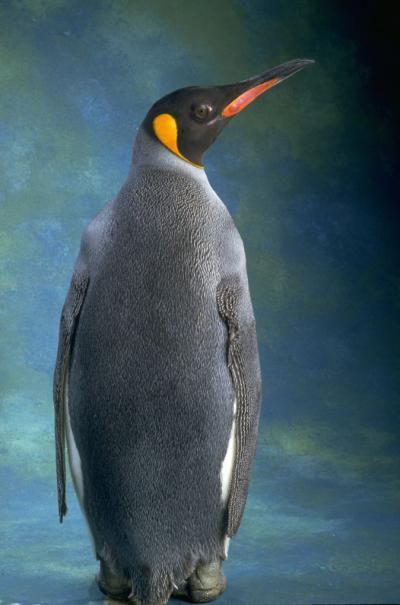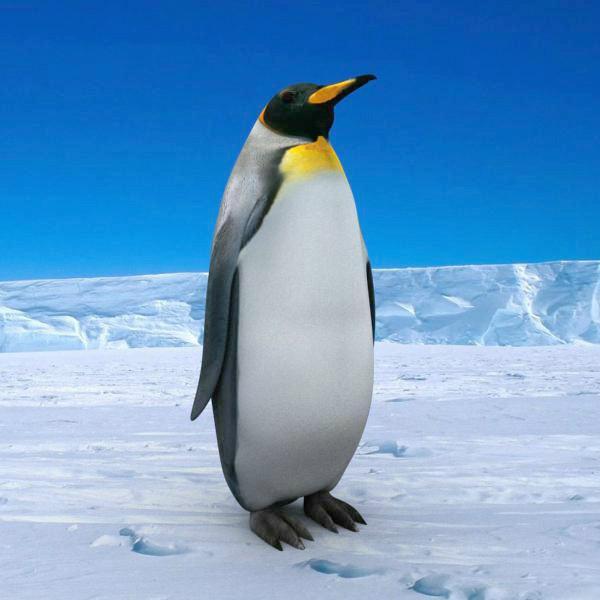The first image is the image on the left, the second image is the image on the right. Evaluate the accuracy of this statement regarding the images: "A total of two penguins are on both images.". Is it true? Answer yes or no. Yes. 